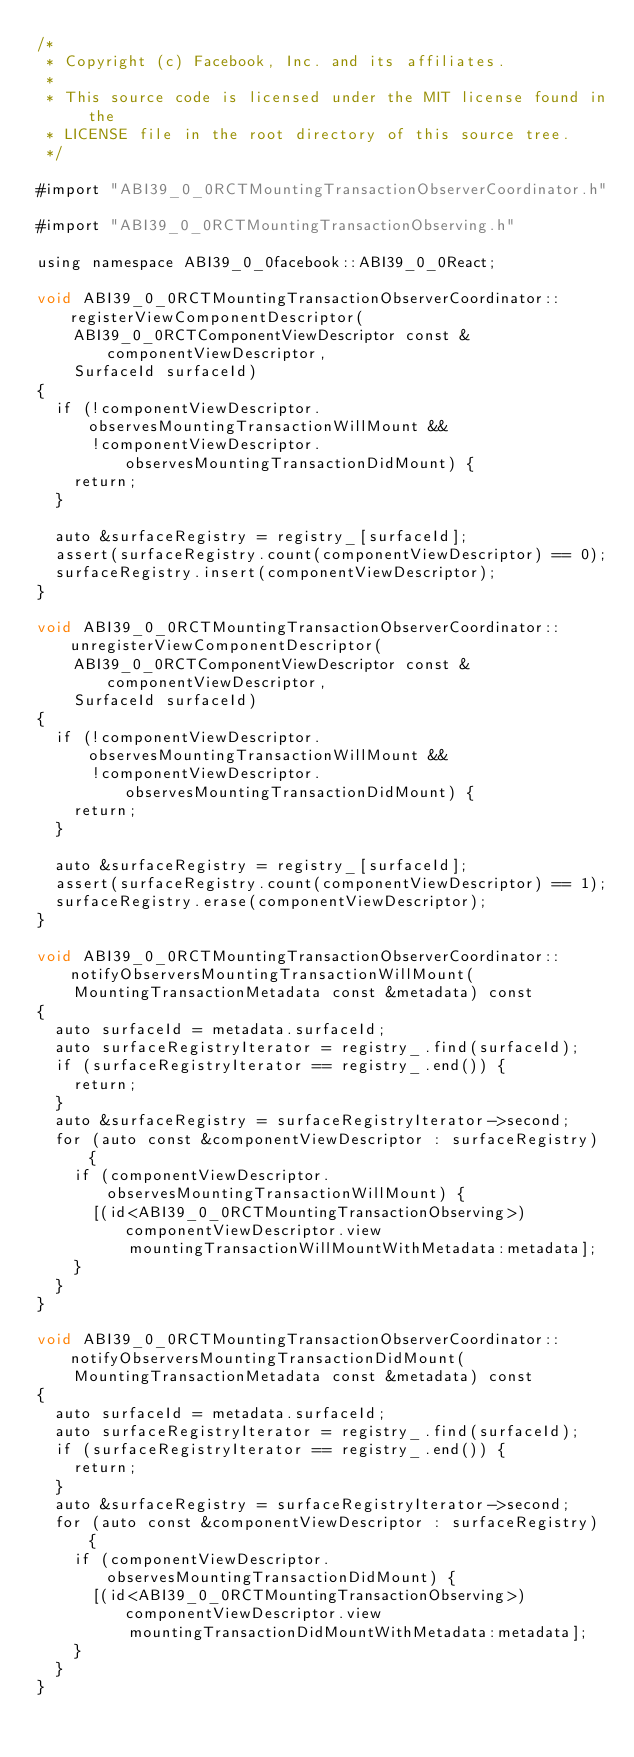<code> <loc_0><loc_0><loc_500><loc_500><_ObjectiveC_>/*
 * Copyright (c) Facebook, Inc. and its affiliates.
 *
 * This source code is licensed under the MIT license found in the
 * LICENSE file in the root directory of this source tree.
 */

#import "ABI39_0_0RCTMountingTransactionObserverCoordinator.h"

#import "ABI39_0_0RCTMountingTransactionObserving.h"

using namespace ABI39_0_0facebook::ABI39_0_0React;

void ABI39_0_0RCTMountingTransactionObserverCoordinator::registerViewComponentDescriptor(
    ABI39_0_0RCTComponentViewDescriptor const &componentViewDescriptor,
    SurfaceId surfaceId)
{
  if (!componentViewDescriptor.observesMountingTransactionWillMount &&
      !componentViewDescriptor.observesMountingTransactionDidMount) {
    return;
  }

  auto &surfaceRegistry = registry_[surfaceId];
  assert(surfaceRegistry.count(componentViewDescriptor) == 0);
  surfaceRegistry.insert(componentViewDescriptor);
}

void ABI39_0_0RCTMountingTransactionObserverCoordinator::unregisterViewComponentDescriptor(
    ABI39_0_0RCTComponentViewDescriptor const &componentViewDescriptor,
    SurfaceId surfaceId)
{
  if (!componentViewDescriptor.observesMountingTransactionWillMount &&
      !componentViewDescriptor.observesMountingTransactionDidMount) {
    return;
  }

  auto &surfaceRegistry = registry_[surfaceId];
  assert(surfaceRegistry.count(componentViewDescriptor) == 1);
  surfaceRegistry.erase(componentViewDescriptor);
}

void ABI39_0_0RCTMountingTransactionObserverCoordinator::notifyObserversMountingTransactionWillMount(
    MountingTransactionMetadata const &metadata) const
{
  auto surfaceId = metadata.surfaceId;
  auto surfaceRegistryIterator = registry_.find(surfaceId);
  if (surfaceRegistryIterator == registry_.end()) {
    return;
  }
  auto &surfaceRegistry = surfaceRegistryIterator->second;
  for (auto const &componentViewDescriptor : surfaceRegistry) {
    if (componentViewDescriptor.observesMountingTransactionWillMount) {
      [(id<ABI39_0_0RCTMountingTransactionObserving>)componentViewDescriptor.view
          mountingTransactionWillMountWithMetadata:metadata];
    }
  }
}

void ABI39_0_0RCTMountingTransactionObserverCoordinator::notifyObserversMountingTransactionDidMount(
    MountingTransactionMetadata const &metadata) const
{
  auto surfaceId = metadata.surfaceId;
  auto surfaceRegistryIterator = registry_.find(surfaceId);
  if (surfaceRegistryIterator == registry_.end()) {
    return;
  }
  auto &surfaceRegistry = surfaceRegistryIterator->second;
  for (auto const &componentViewDescriptor : surfaceRegistry) {
    if (componentViewDescriptor.observesMountingTransactionDidMount) {
      [(id<ABI39_0_0RCTMountingTransactionObserving>)componentViewDescriptor.view
          mountingTransactionDidMountWithMetadata:metadata];
    }
  }
}
</code> 